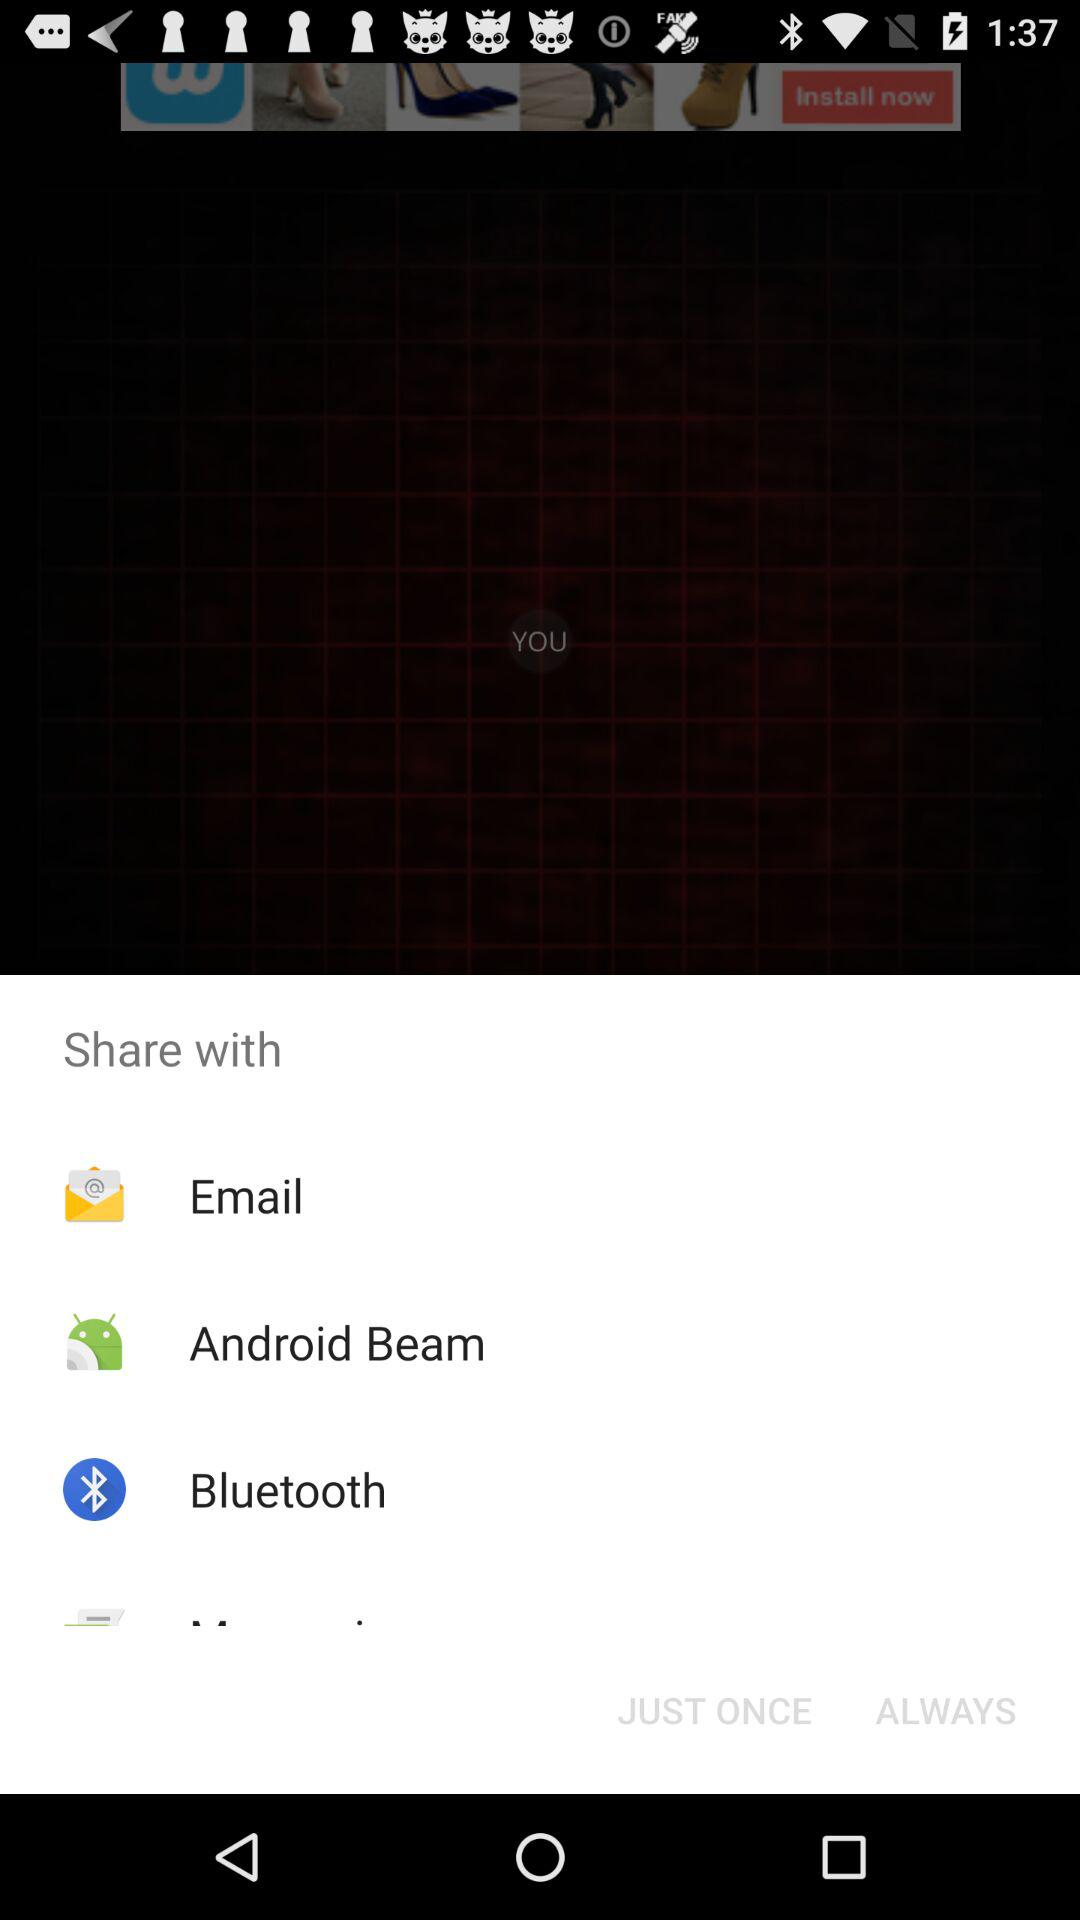Which applications are used to share the data? The applications are "Email", "Android Beam" and "Bluetooth". 